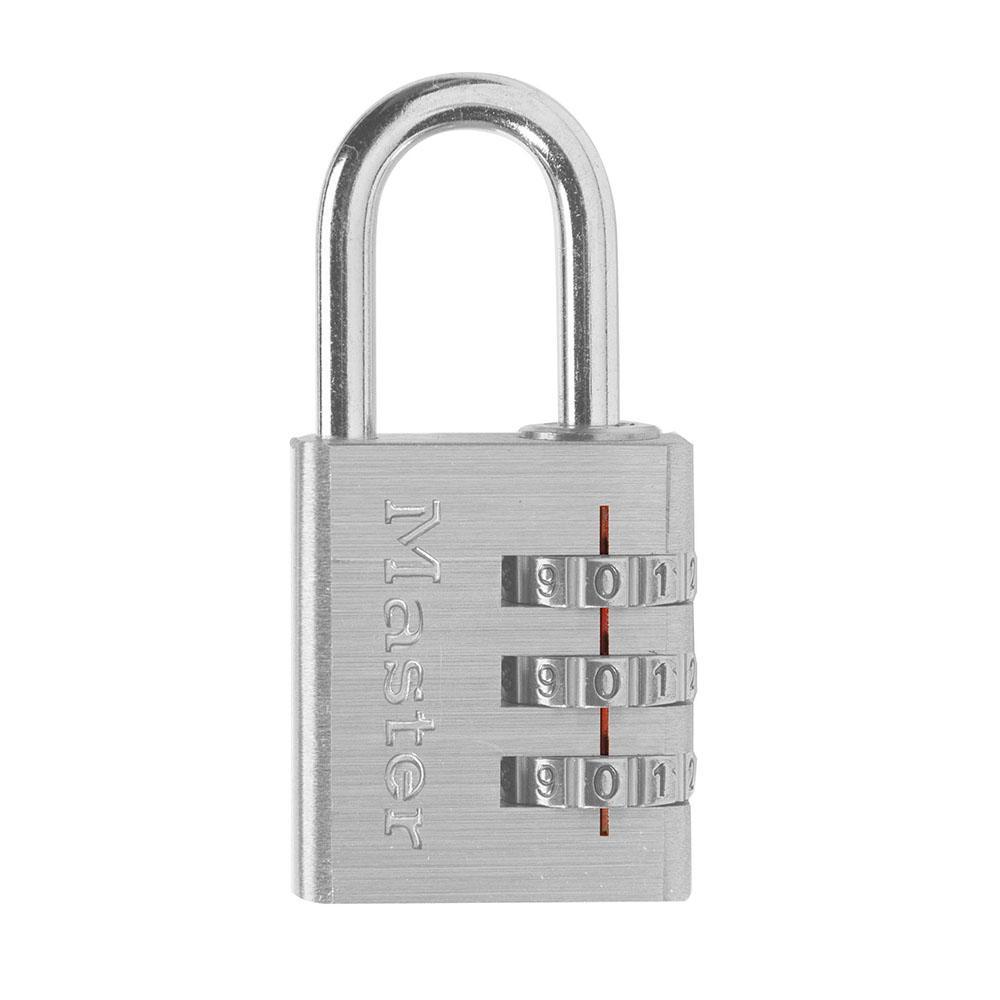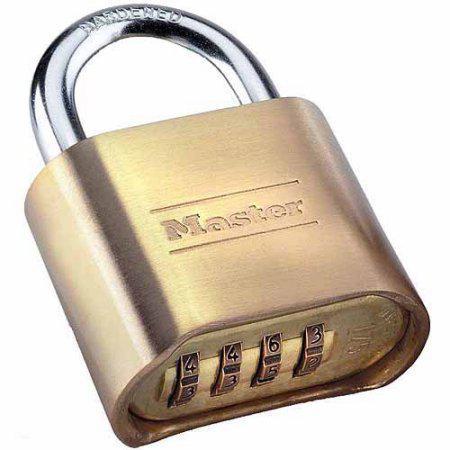The first image is the image on the left, the second image is the image on the right. Considering the images on both sides, is "One lock is gold and squarish, and the other lock is round with a black face." valid? Answer yes or no. No. The first image is the image on the left, the second image is the image on the right. Considering the images on both sides, is "Each of two different colored padlocks is a similar shape, but one has number belts on the front and side, while the other has number belts on the bottom." valid? Answer yes or no. Yes. 